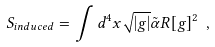<formula> <loc_0><loc_0><loc_500><loc_500>S _ { i n d u c e d } = \int d ^ { 4 } x \sqrt { | g | } \tilde { \alpha } R [ g ] ^ { 2 } \ ,</formula> 